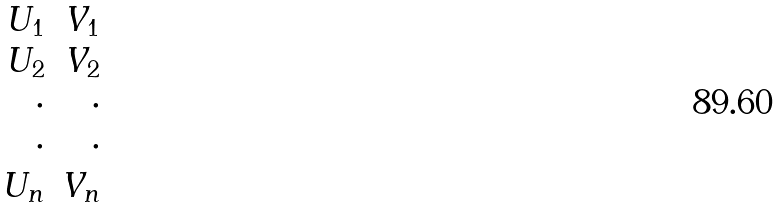Convert formula to latex. <formula><loc_0><loc_0><loc_500><loc_500>\begin{array} { r r } U _ { 1 } & V _ { 1 } \\ U _ { 2 } & V _ { 2 } \\ \cdot & \cdot \\ \cdot & \cdot \\ U _ { n } & V _ { n } \end{array}</formula> 